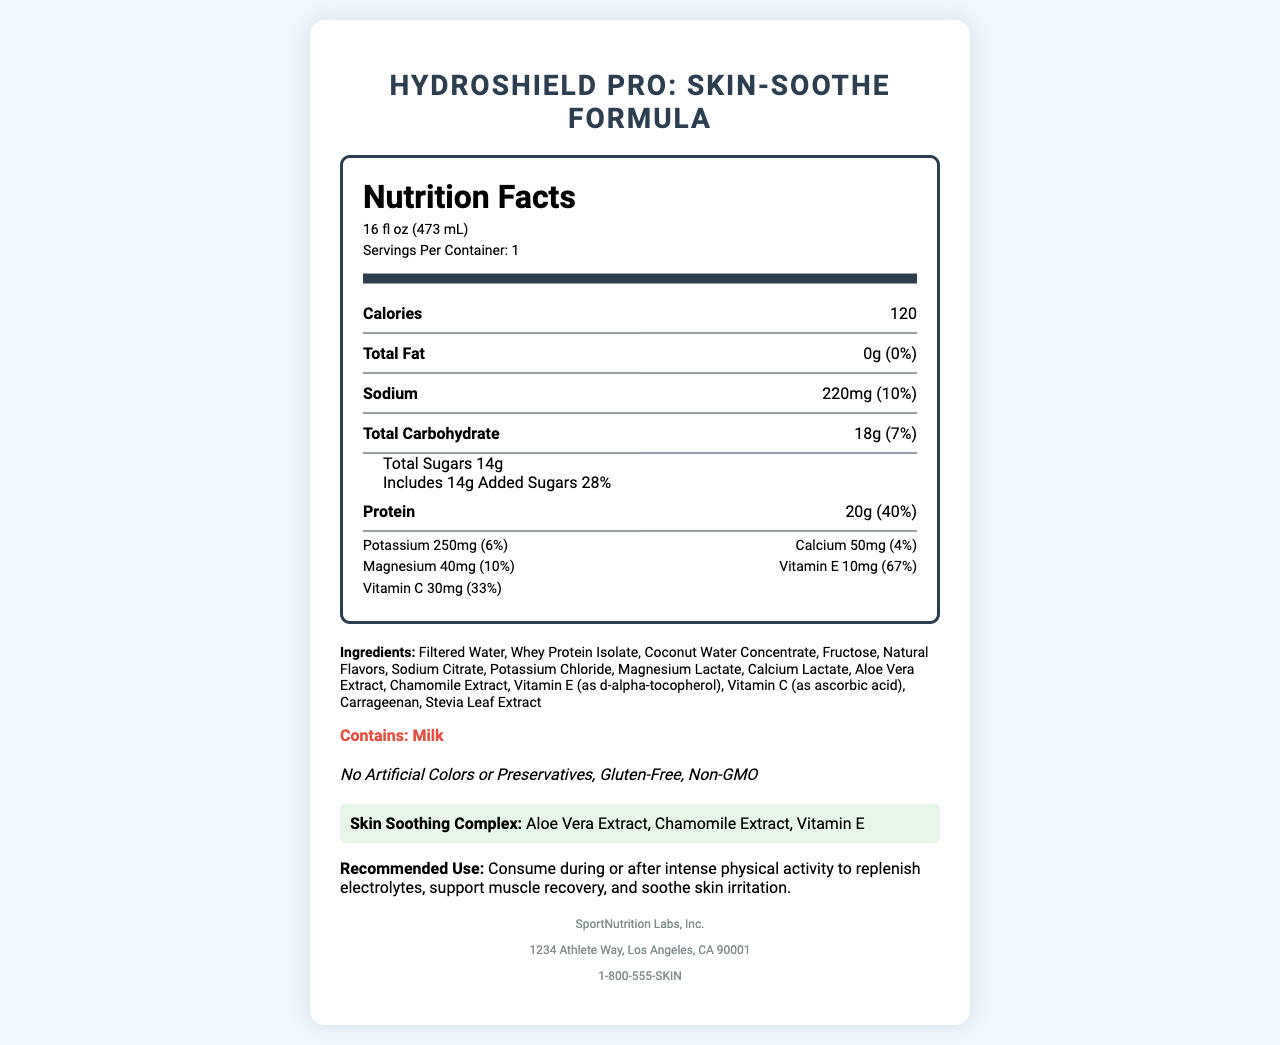what is the serving size for HydroShield Pro: Skin-Soothe Formula? The serving size is provided at the beginning of the document, under the nutrition facts header.
Answer: 16 fl oz (473 mL) how many calories are in one serving of HydroShield Pro: Skin-Soothe Formula? The calories per serving are listed in the main nutrition information section.
Answer: 120 what ingredients are included in the skin-soothing complex? The skin-soothing complex is listed toward the bottom of the document.
Answer: Aloe Vera Extract, Chamomile Extract, Vitamin E how much protein does one serving of HydroShield Pro: Skin-Soothe Formula contain? The amount of protein is clearly stated under the main nutrition information.
Answer: 20g what is the daily value percentage for vitamin E in HydroShield Pro: Skin-Soothe Formula? The daily value percentage for vitamin E is provided alongside its quantity in the vitamin information section.
Answer: 67% which of the following is not a special feature of HydroShield Pro: Skin-Soothe Formula?
A. No Artificial Colors or Preservatives
B. Vegan
C. Gluten-Free
D. Non-GMO The special features section lists "No Artificial Colors or Preservatives," "Gluten-Free," and "Non-GMO." "Vegan" is not mentioned.
Answer: B what is the daily value percentage of magnesium? 
A. 4%
B. 6%
C. 10%
D. 33% The daily value percentage of magnesium is shown as 10% in the vitamin information section.
Answer: C is HydroShield Pro: Skin-Soothe Formula gluten-free? The special features section explicitly states that the product is gluten-free.
Answer: Yes summarize the main components and purpose of HydroShield Pro: Skin-Soothe Formula. The summary covers the primary nutrients, ingredients, intended use, and special features as described in the document.
Answer: HydroShield Pro: Skin-Soothe Formula is a high-protein sports drink with added electrolytes and skin-soothing ingredients. It contains 20g of protein, 250mg of potassium, and 10mg of vitamin E, among other nutrients. The ingredients include whey protein isolate, coconut water concentrate, and aloe vera extract. The drink is designed to replenish electrolytes, support muscle recovery, and soothe skin irritation. It is gluten-free and contains no artificial colors or preservatives. what is the estimated address of the manufacturer? The manufacturer's address is given at the end of the document under the manufacturer information section.
Answer: 1234 Athlete Way, Los Angeles, CA 90001 can people with milk allergies consume HydroShield Pro: Skin-Soothe Formula? The allergen warning clearly states that the product contains milk, making it unsuitable for people with milk allergies.
Answer: No does the document provide information on the sugar source used in HydroShield Pro: Skin-Soothe Formula? The ingredients list includes "Fructose," which is the source of sugar.
Answer: Yes what is the phone number for SportNutrition Labs, Inc.? The phone number is part of the manufacturer's details at the end of the document.
Answer: 1-800-555-SKIN how does HydroShield Pro: Skin-Soothe Formula support athletic performance and skin health? This interpretation uses information from multiple sections, including the nutrients, ingredients, skin-soothing complex, and recommended use.
Answer: The product supports athletic performance by replenishing electrolytes, providing hydration with coconut water concentrate, and delivering 20g of protein for muscle recovery. Skin health is supported by ingredients like aloe vera extract, chamomile extract, and vitamin E, which have soothing properties. are there any artificial colors in HydroShield Pro: Skin-Soothe Formula? The special features section states that the product contains no artificial colors.
Answer: No is HydroShield Pro: Skin-Soothe Formula vegan-friendly? The document does not provide information on whether the product is suitable for vegans. It mentions it contains milk, which suggests it might not be vegan, but no explicit information on vegan status is given.
Answer: Not enough information 